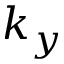Convert formula to latex. <formula><loc_0><loc_0><loc_500><loc_500>k _ { y }</formula> 